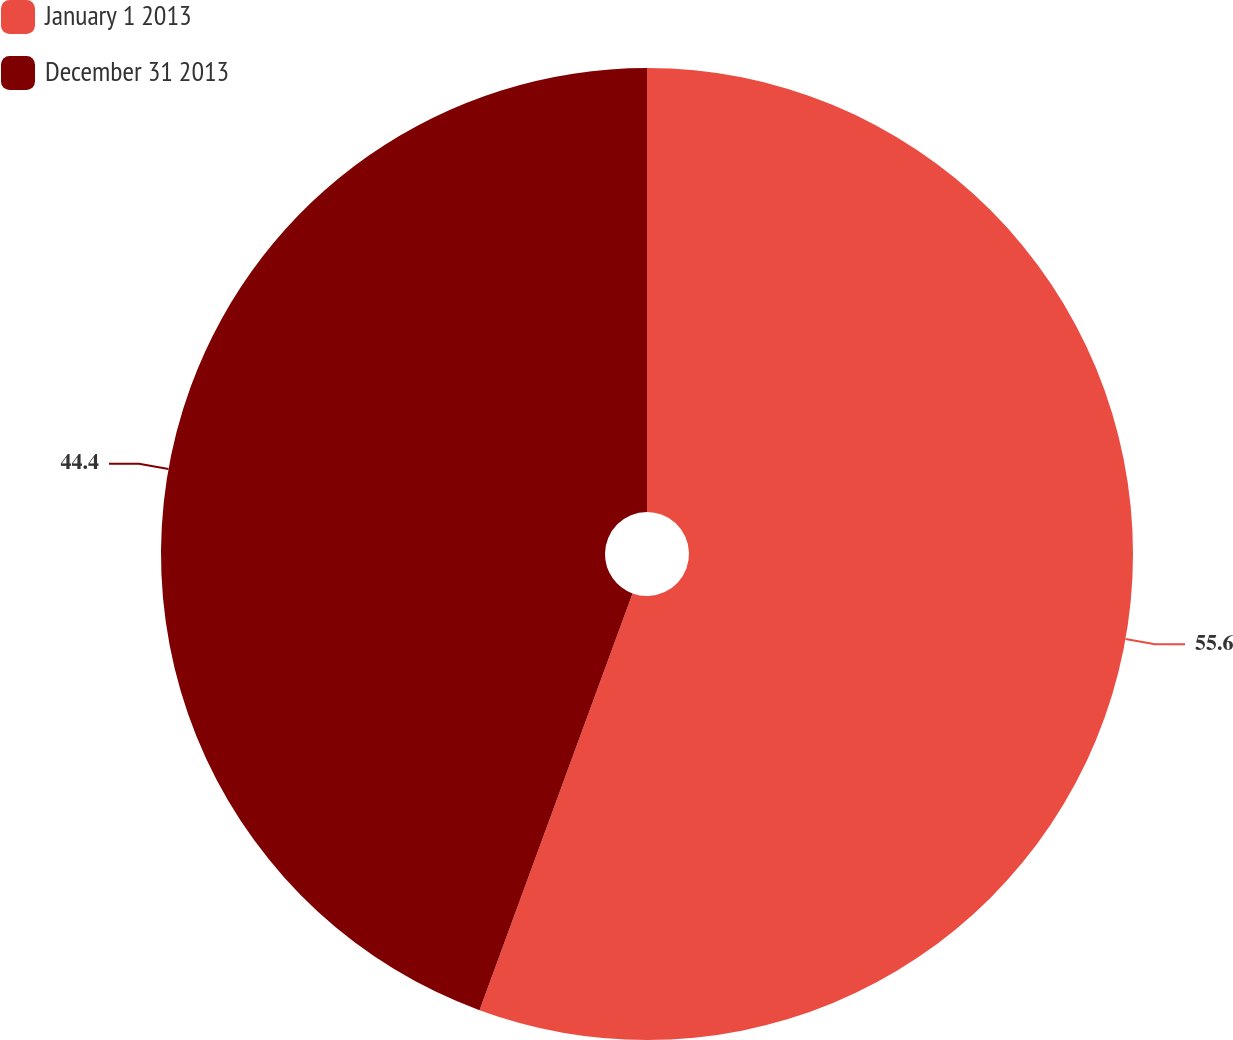<chart> <loc_0><loc_0><loc_500><loc_500><pie_chart><fcel>January 1 2013<fcel>December 31 2013<nl><fcel>55.6%<fcel>44.4%<nl></chart> 